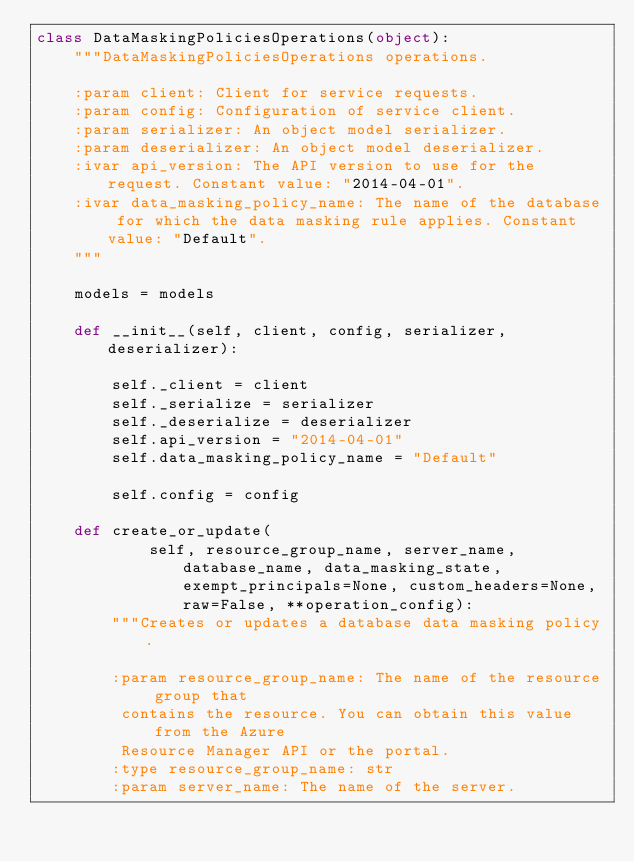Convert code to text. <code><loc_0><loc_0><loc_500><loc_500><_Python_>class DataMaskingPoliciesOperations(object):
    """DataMaskingPoliciesOperations operations.

    :param client: Client for service requests.
    :param config: Configuration of service client.
    :param serializer: An object model serializer.
    :param deserializer: An object model deserializer.
    :ivar api_version: The API version to use for the request. Constant value: "2014-04-01".
    :ivar data_masking_policy_name: The name of the database for which the data masking rule applies. Constant value: "Default".
    """

    models = models

    def __init__(self, client, config, serializer, deserializer):

        self._client = client
        self._serialize = serializer
        self._deserialize = deserializer
        self.api_version = "2014-04-01"
        self.data_masking_policy_name = "Default"

        self.config = config

    def create_or_update(
            self, resource_group_name, server_name, database_name, data_masking_state, exempt_principals=None, custom_headers=None, raw=False, **operation_config):
        """Creates or updates a database data masking policy.

        :param resource_group_name: The name of the resource group that
         contains the resource. You can obtain this value from the Azure
         Resource Manager API or the portal.
        :type resource_group_name: str
        :param server_name: The name of the server.</code> 